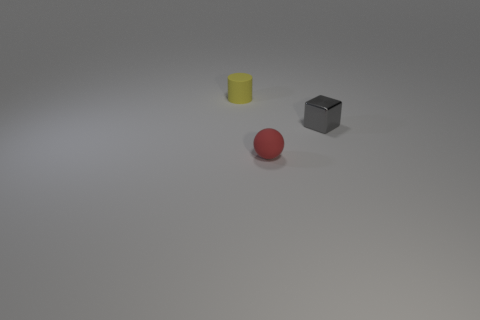What materials do these objects seem to be made of? The three objects in the image appear to be made of different materials. The yellow one seems to be rubbery, suggested by its slightly shiny and smooth surface. The gray cube looks like it could be made of a matte metal or plastic due to its dull finish. And the red spherical object seems like it could be plastic, given its uniform surface and reflective quality. 